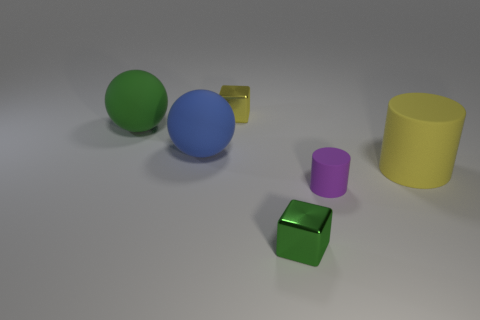Add 1 big blue matte things. How many objects exist? 7 Subtract all cubes. How many objects are left? 4 Subtract all large rubber balls. Subtract all tiny yellow blocks. How many objects are left? 3 Add 4 yellow matte cylinders. How many yellow matte cylinders are left? 5 Add 5 green matte objects. How many green matte objects exist? 6 Subtract 1 yellow cylinders. How many objects are left? 5 